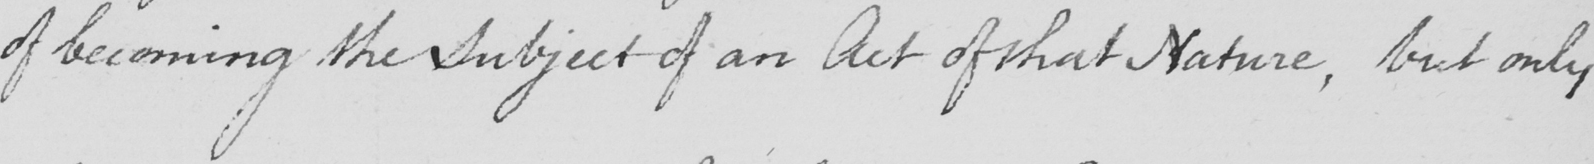What text is written in this handwritten line? of becoming the Subject of an Act of that Nature , but only 